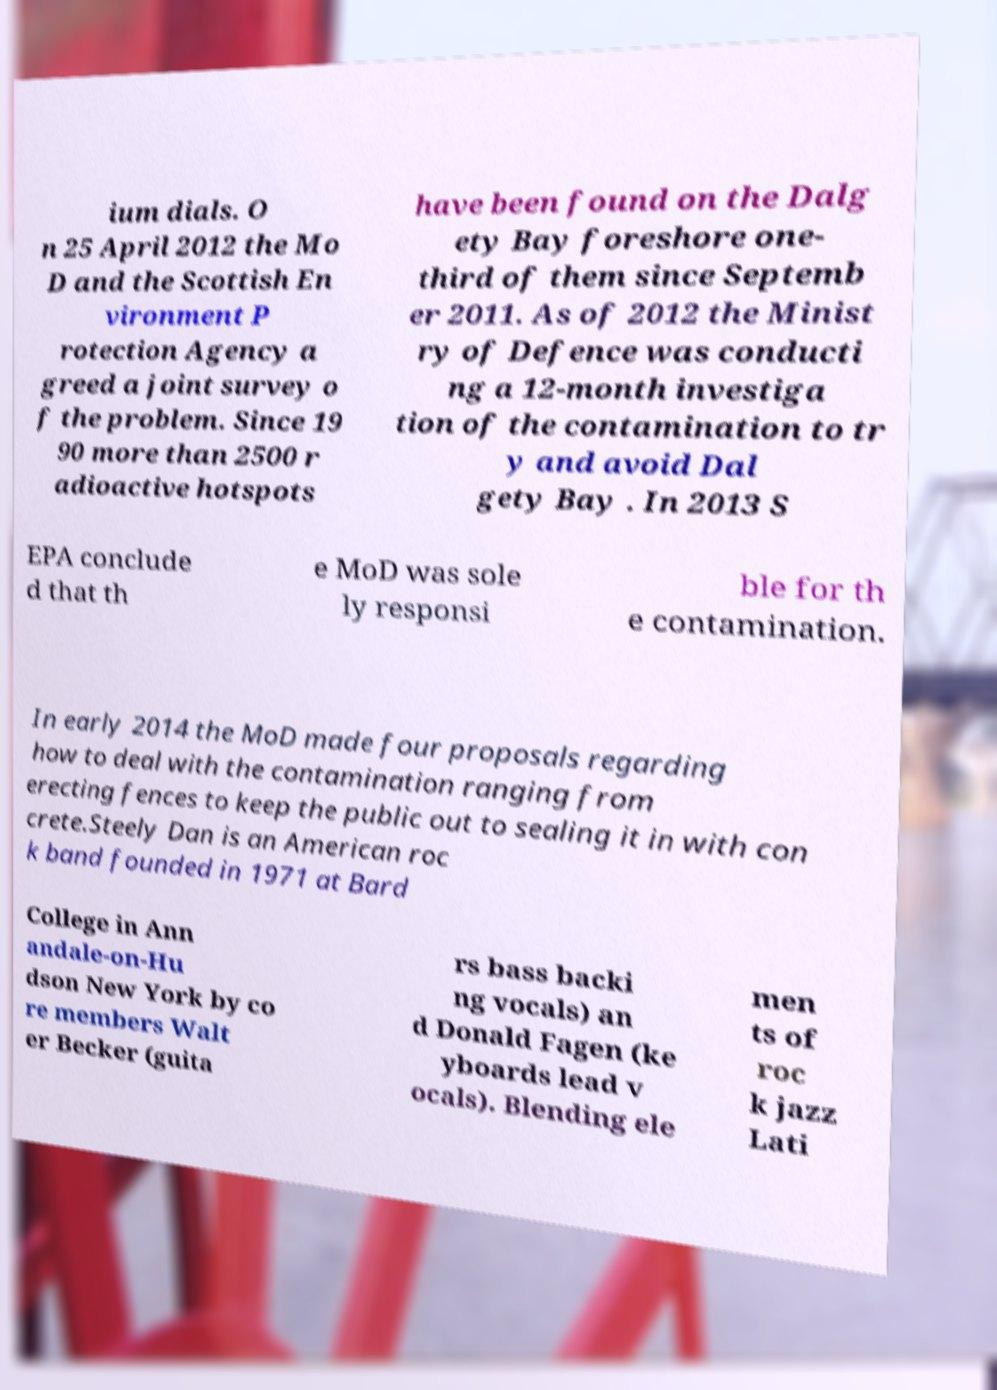Please read and relay the text visible in this image. What does it say? ium dials. O n 25 April 2012 the Mo D and the Scottish En vironment P rotection Agency a greed a joint survey o f the problem. Since 19 90 more than 2500 r adioactive hotspots have been found on the Dalg ety Bay foreshore one- third of them since Septemb er 2011. As of 2012 the Minist ry of Defence was conducti ng a 12-month investiga tion of the contamination to tr y and avoid Dal gety Bay . In 2013 S EPA conclude d that th e MoD was sole ly responsi ble for th e contamination. In early 2014 the MoD made four proposals regarding how to deal with the contamination ranging from erecting fences to keep the public out to sealing it in with con crete.Steely Dan is an American roc k band founded in 1971 at Bard College in Ann andale-on-Hu dson New York by co re members Walt er Becker (guita rs bass backi ng vocals) an d Donald Fagen (ke yboards lead v ocals). Blending ele men ts of roc k jazz Lati 